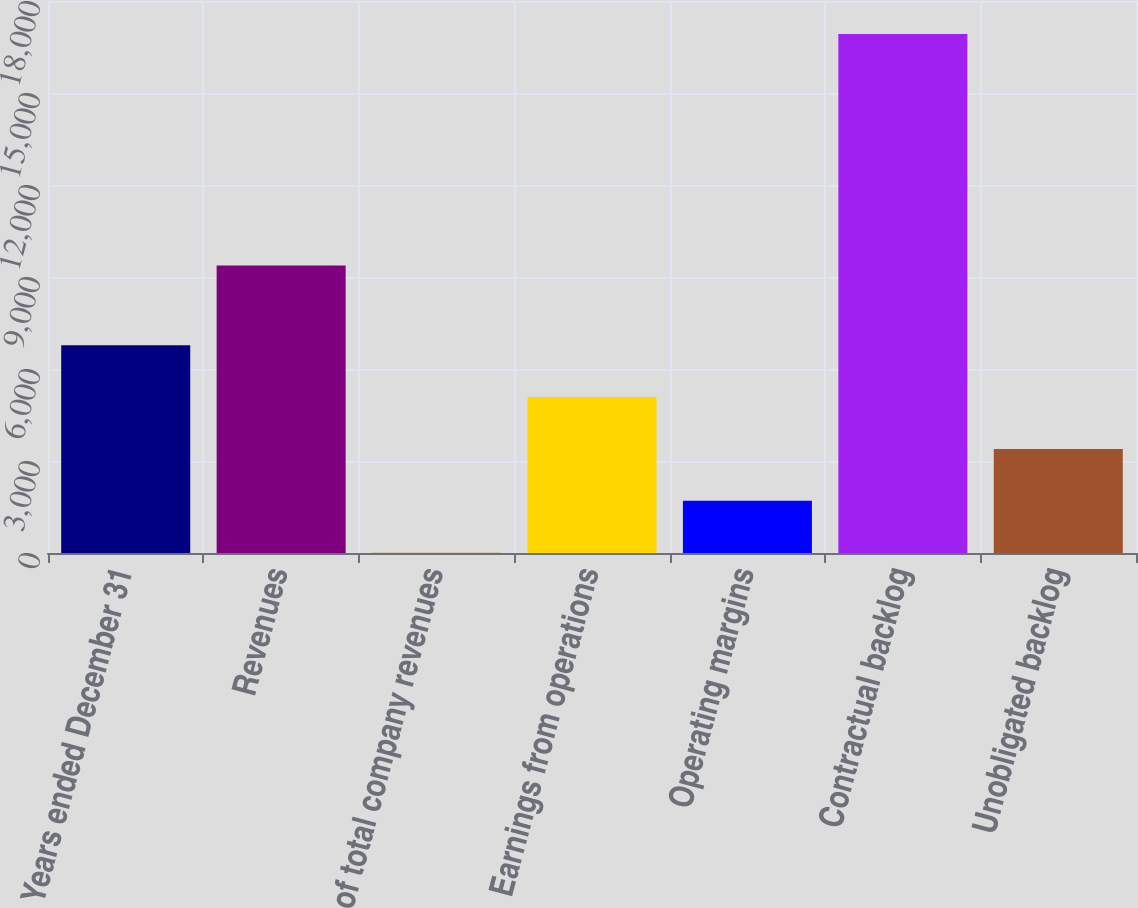<chart> <loc_0><loc_0><loc_500><loc_500><bar_chart><fcel>Years ended December 31<fcel>Revenues<fcel>of total company revenues<fcel>Earnings from operations<fcel>Operating margins<fcel>Contractual backlog<fcel>Unobligated backlog<nl><fcel>6774<fcel>9378<fcel>10<fcel>5083<fcel>1701<fcel>16920<fcel>3392<nl></chart> 